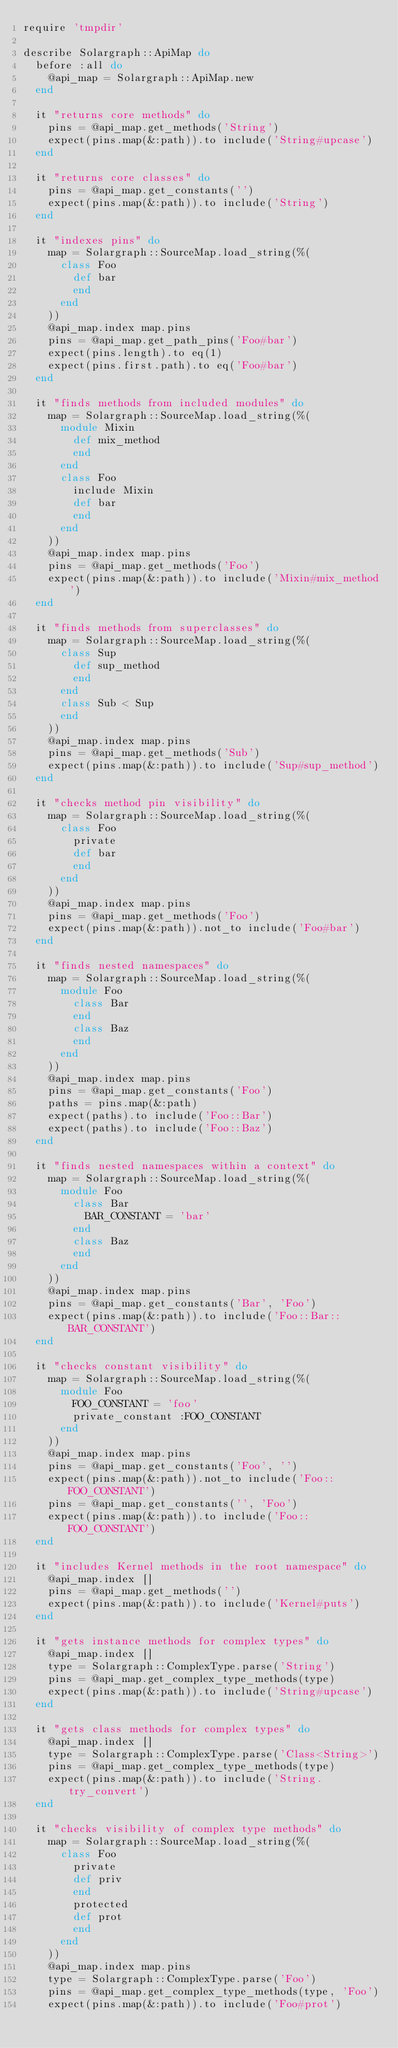Convert code to text. <code><loc_0><loc_0><loc_500><loc_500><_Ruby_>require 'tmpdir'

describe Solargraph::ApiMap do
  before :all do
    @api_map = Solargraph::ApiMap.new
  end

  it "returns core methods" do
    pins = @api_map.get_methods('String')
    expect(pins.map(&:path)).to include('String#upcase')
  end

  it "returns core classes" do
    pins = @api_map.get_constants('')
    expect(pins.map(&:path)).to include('String')
  end

  it "indexes pins" do
    map = Solargraph::SourceMap.load_string(%(
      class Foo
        def bar
        end
      end
    ))
    @api_map.index map.pins
    pins = @api_map.get_path_pins('Foo#bar')
    expect(pins.length).to eq(1)
    expect(pins.first.path).to eq('Foo#bar')
  end

  it "finds methods from included modules" do
    map = Solargraph::SourceMap.load_string(%(
      module Mixin
        def mix_method
        end
      end
      class Foo
        include Mixin
        def bar
        end
      end
    ))
    @api_map.index map.pins
    pins = @api_map.get_methods('Foo')
    expect(pins.map(&:path)).to include('Mixin#mix_method')
  end

  it "finds methods from superclasses" do
    map = Solargraph::SourceMap.load_string(%(
      class Sup
        def sup_method
        end
      end
      class Sub < Sup
      end
    ))
    @api_map.index map.pins
    pins = @api_map.get_methods('Sub')
    expect(pins.map(&:path)).to include('Sup#sup_method')
  end

  it "checks method pin visibility" do
    map = Solargraph::SourceMap.load_string(%(
      class Foo
        private
        def bar
        end
      end
    ))
    @api_map.index map.pins
    pins = @api_map.get_methods('Foo')
    expect(pins.map(&:path)).not_to include('Foo#bar')
  end

  it "finds nested namespaces" do
    map = Solargraph::SourceMap.load_string(%(
      module Foo
        class Bar
        end
        class Baz
        end
      end
    ))
    @api_map.index map.pins
    pins = @api_map.get_constants('Foo')
    paths = pins.map(&:path)
    expect(paths).to include('Foo::Bar')
    expect(paths).to include('Foo::Baz')
  end

  it "finds nested namespaces within a context" do
    map = Solargraph::SourceMap.load_string(%(
      module Foo
        class Bar
          BAR_CONSTANT = 'bar'
        end
        class Baz
        end
      end
    ))
    @api_map.index map.pins
    pins = @api_map.get_constants('Bar', 'Foo')
    expect(pins.map(&:path)).to include('Foo::Bar::BAR_CONSTANT')
  end

  it "checks constant visibility" do
    map = Solargraph::SourceMap.load_string(%(
      module Foo
        FOO_CONSTANT = 'foo'
        private_constant :FOO_CONSTANT
      end
    ))
    @api_map.index map.pins
    pins = @api_map.get_constants('Foo', '')
    expect(pins.map(&:path)).not_to include('Foo::FOO_CONSTANT')
    pins = @api_map.get_constants('', 'Foo')
    expect(pins.map(&:path)).to include('Foo::FOO_CONSTANT')
  end

  it "includes Kernel methods in the root namespace" do
    @api_map.index []
    pins = @api_map.get_methods('')
    expect(pins.map(&:path)).to include('Kernel#puts')
  end

  it "gets instance methods for complex types" do
    @api_map.index []
    type = Solargraph::ComplexType.parse('String')
    pins = @api_map.get_complex_type_methods(type)
    expect(pins.map(&:path)).to include('String#upcase')
  end

  it "gets class methods for complex types" do
    @api_map.index []
    type = Solargraph::ComplexType.parse('Class<String>')
    pins = @api_map.get_complex_type_methods(type)
    expect(pins.map(&:path)).to include('String.try_convert')
  end

  it "checks visibility of complex type methods" do
    map = Solargraph::SourceMap.load_string(%(
      class Foo
        private
        def priv
        end
        protected
        def prot
        end
      end
    ))
    @api_map.index map.pins
    type = Solargraph::ComplexType.parse('Foo')
    pins = @api_map.get_complex_type_methods(type, 'Foo')
    expect(pins.map(&:path)).to include('Foo#prot')</code> 